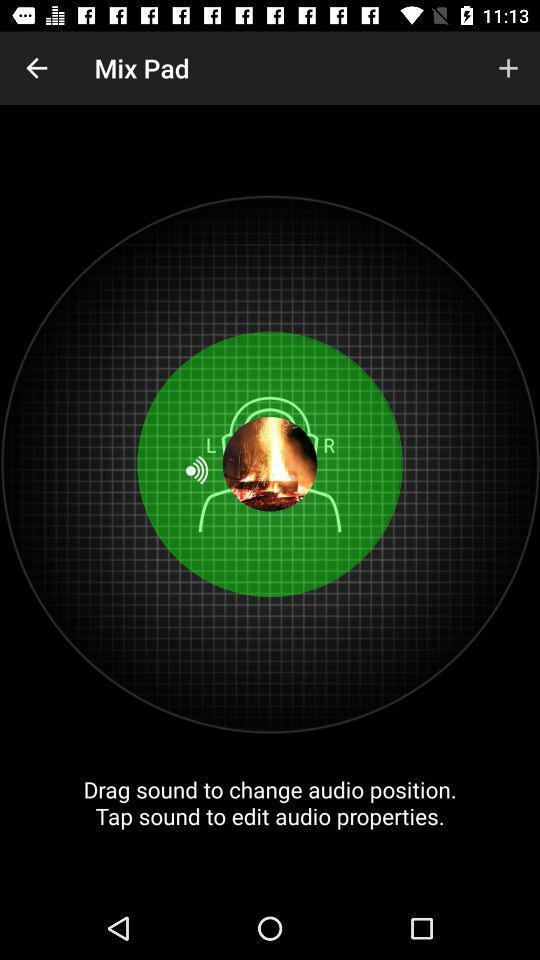What is the application name? The application name is "Mix Pad". 